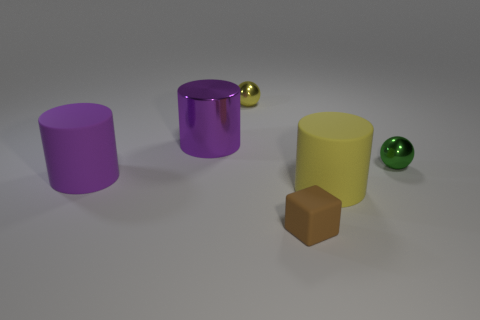Do the matte thing right of the tiny matte block and the rubber block that is right of the big metal thing have the same size?
Your response must be concise. No. How many cubes are either shiny objects or matte objects?
Ensure brevity in your answer.  1. Are the big purple object that is to the left of the shiny cylinder and the brown block made of the same material?
Provide a short and direct response. Yes. What number of other objects are the same size as the brown rubber block?
Your response must be concise. 2. What number of large things are either gray metallic objects or green objects?
Offer a terse response. 0. Do the large shiny cylinder and the block have the same color?
Provide a short and direct response. No. Is the number of small green things in front of the tiny green metallic ball greater than the number of big yellow things left of the large shiny thing?
Offer a very short reply. No. There is a tiny metal sphere that is to the right of the small rubber thing; is it the same color as the block?
Offer a terse response. No. Is there any other thing of the same color as the big metallic object?
Offer a very short reply. Yes. Are there more large cylinders to the right of the small green thing than large red spheres?
Offer a very short reply. No. 